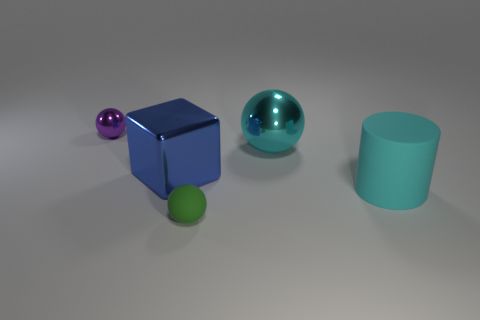What color is the shiny object in front of the cyan shiny object?
Offer a very short reply. Blue. There is a shiny sphere that is to the left of the metallic block; are there any blue things that are behind it?
Your answer should be very brief. No. Are there fewer green cylinders than big blue shiny things?
Keep it short and to the point. Yes. The sphere that is behind the metal object that is to the right of the matte ball is made of what material?
Your response must be concise. Metal. Is the cyan matte cylinder the same size as the purple metal sphere?
Provide a succinct answer. No. What number of things are blue cubes or purple metal balls?
Provide a short and direct response. 2. There is a ball that is both behind the rubber sphere and left of the large shiny sphere; how big is it?
Your answer should be very brief. Small. Are there fewer tiny shiny balls on the left side of the metallic block than small blue matte blocks?
Give a very brief answer. No. What is the shape of the purple object that is the same material as the large cyan sphere?
Make the answer very short. Sphere. Does the tiny object to the left of the green object have the same shape as the big shiny thing on the left side of the matte ball?
Your answer should be compact. No. 